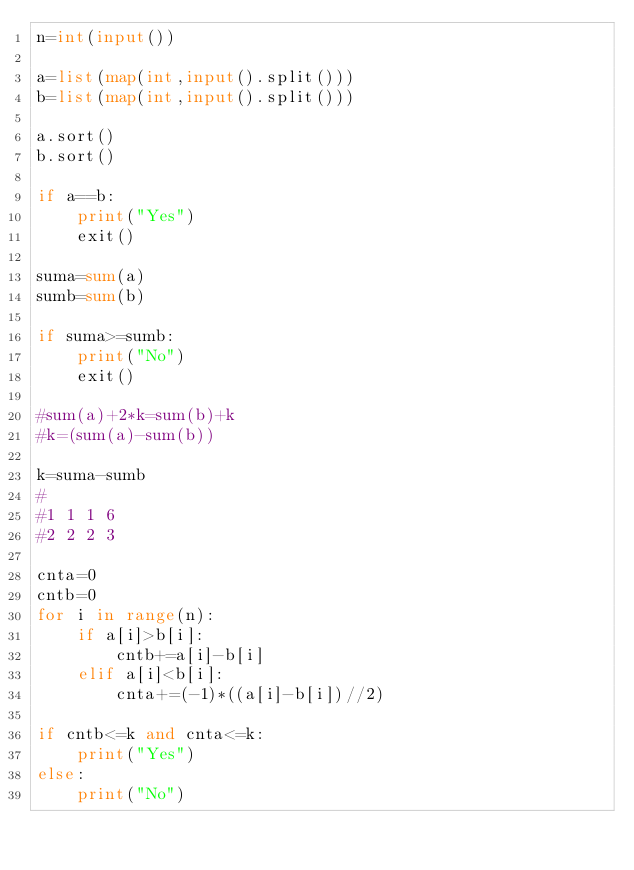<code> <loc_0><loc_0><loc_500><loc_500><_Python_>n=int(input())

a=list(map(int,input().split()))
b=list(map(int,input().split()))

a.sort()
b.sort()

if a==b:
    print("Yes")
    exit()

suma=sum(a)
sumb=sum(b)

if suma>=sumb:
    print("No")
    exit()

#sum(a)+2*k=sum(b)+k
#k=(sum(a)-sum(b))

k=suma-sumb
#
#1 1 1 6
#2 2 2 3

cnta=0
cntb=0
for i in range(n):
    if a[i]>b[i]:
        cntb+=a[i]-b[i]
    elif a[i]<b[i]:
        cnta+=(-1)*((a[i]-b[i])//2)

if cntb<=k and cnta<=k:
    print("Yes")
else:
    print("No")
</code> 